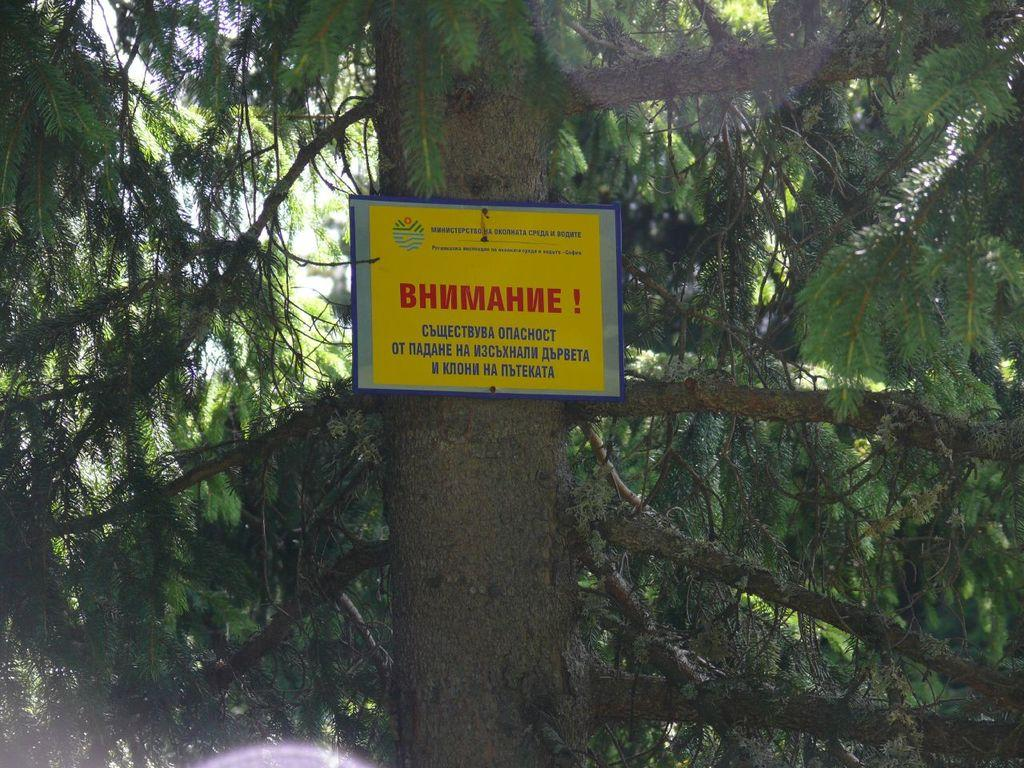What type of plant can be seen in the image? There is a tree in the image. What colors are present on the tree? The tree is green and brown in color. What object is located near the tree? There is a board near the tree. What colors are present on the board? The board is yellow, blue, and red in color. What can be seen in the background of the image? The sky is visible in the background of the image. Can you tell me how many worms are crawling on the tree in the image? There are no worms present on the tree in the image. Is there a toad sitting on the board in the image? There is no toad present on the board in the image. 